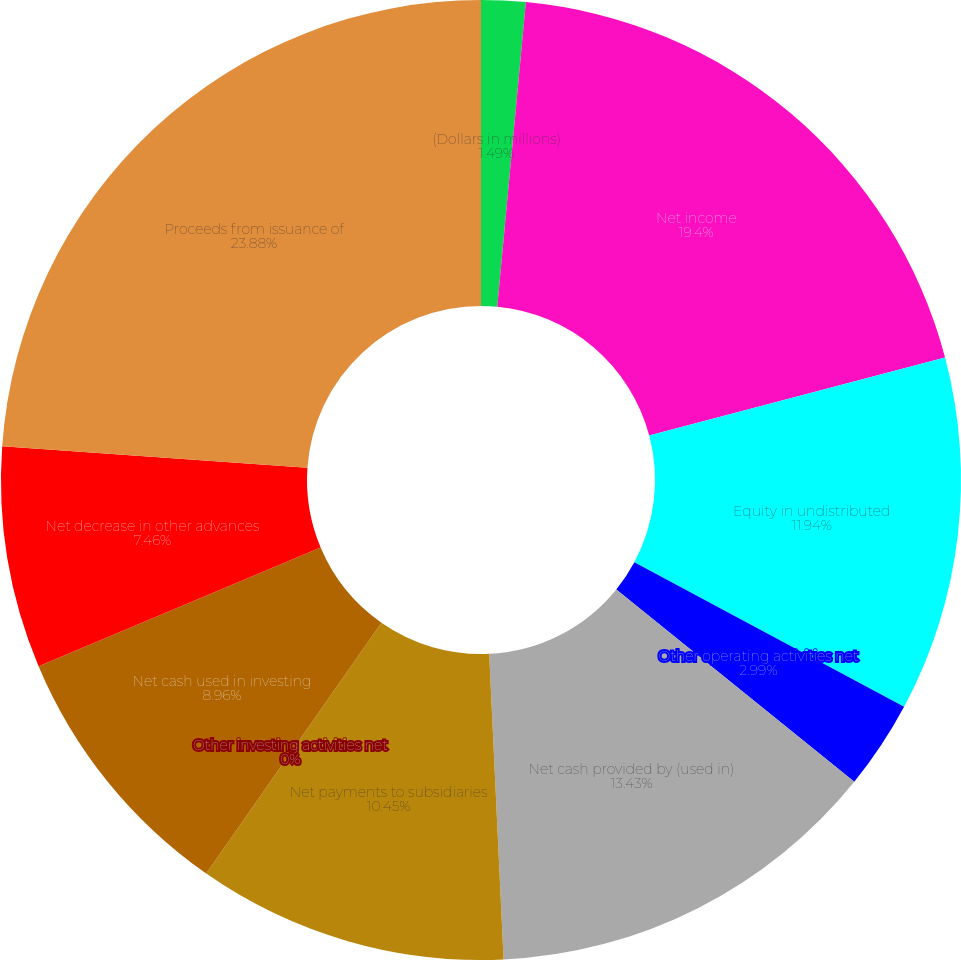Convert chart. <chart><loc_0><loc_0><loc_500><loc_500><pie_chart><fcel>(Dollars in millions)<fcel>Net income<fcel>Equity in undistributed<fcel>Other operating activities net<fcel>Net cash provided by (used in)<fcel>Net payments to subsidiaries<fcel>Other investing activities net<fcel>Net cash used in investing<fcel>Net decrease in other advances<fcel>Proceeds from issuance of<nl><fcel>1.49%<fcel>19.4%<fcel>11.94%<fcel>2.99%<fcel>13.43%<fcel>10.45%<fcel>0.0%<fcel>8.96%<fcel>7.46%<fcel>23.88%<nl></chart> 